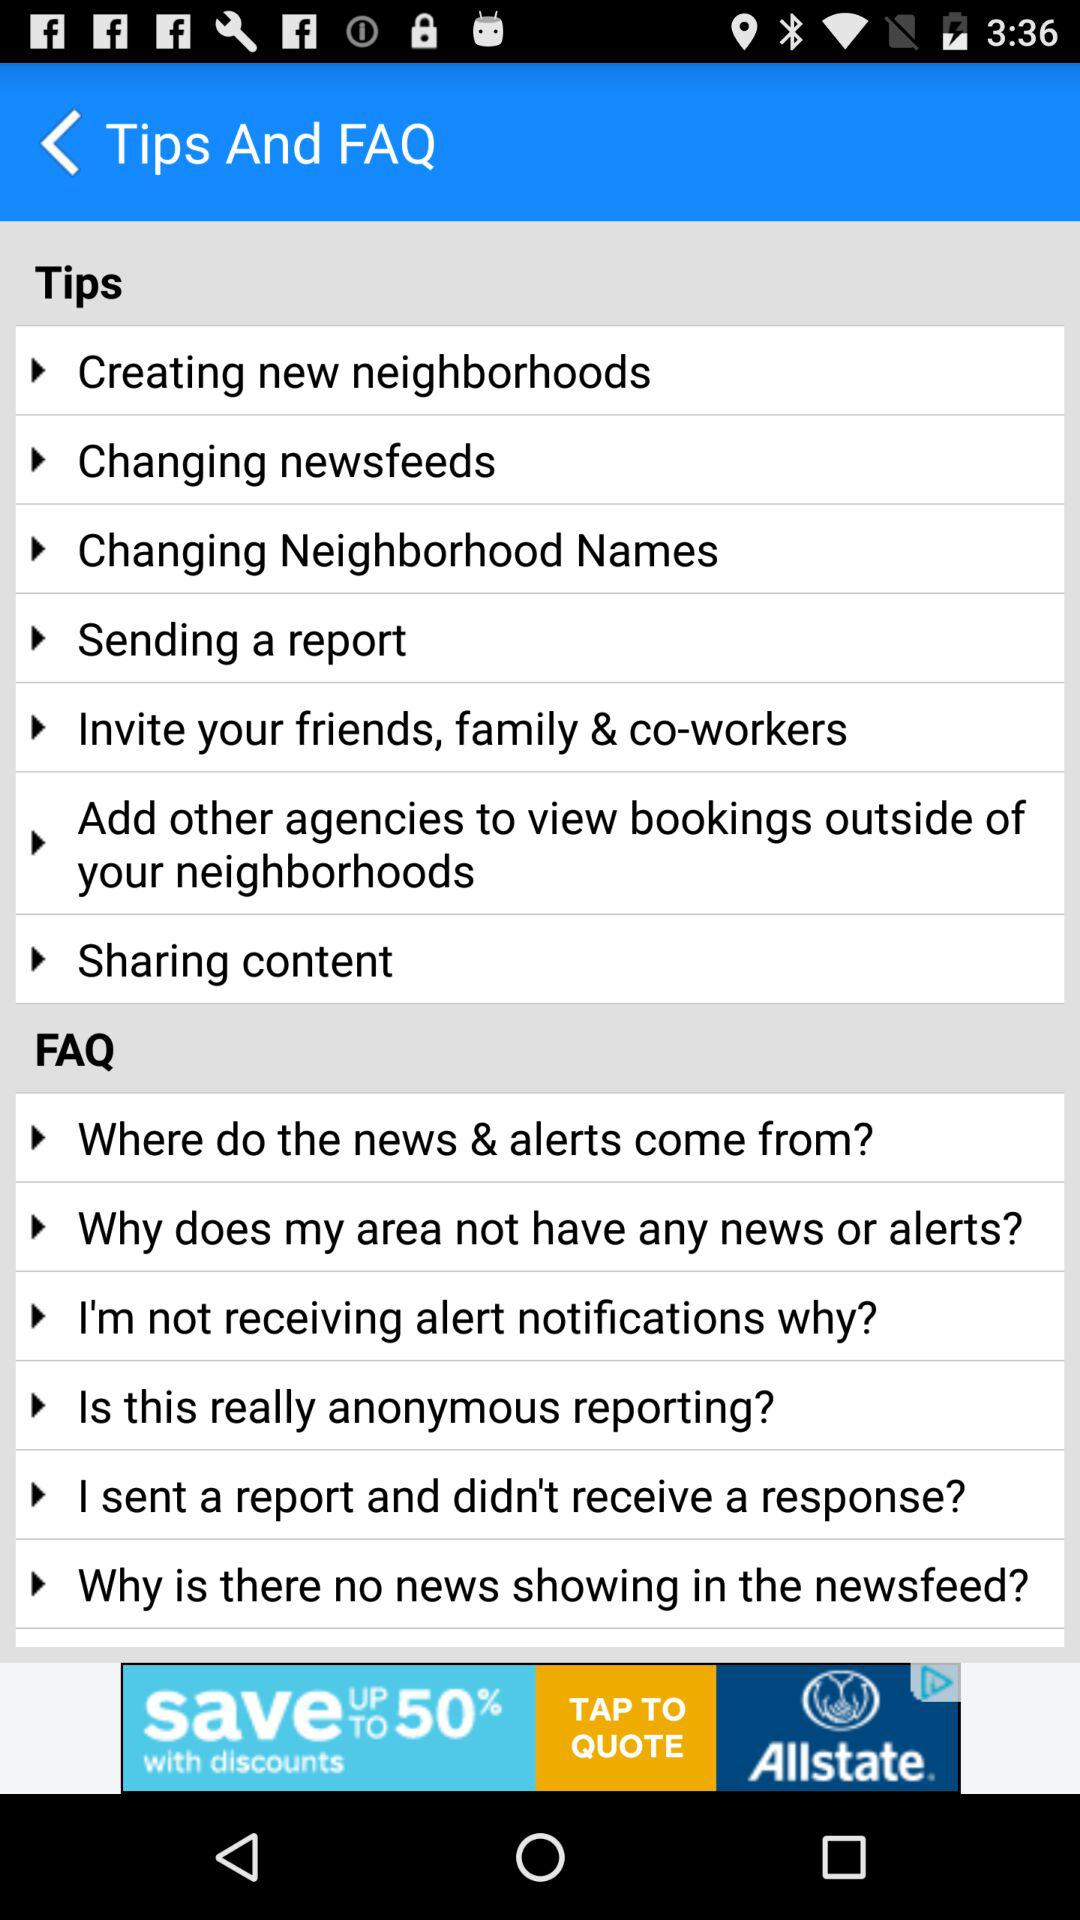What are the tips? The tips are "Creating new neighborhoods", "Changing newsfeeds", "Changing Neighborhood Names", "Sending a report", "Invite your friends, family & co-workers", "Add other agencies to view bookings outside of your neighborhoods" and "Sharing content". 